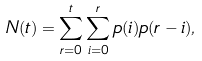<formula> <loc_0><loc_0><loc_500><loc_500>N ( t ) = \sum _ { r = 0 } ^ { t } \sum _ { i = 0 } ^ { r } p ( i ) p ( r - i ) ,</formula> 